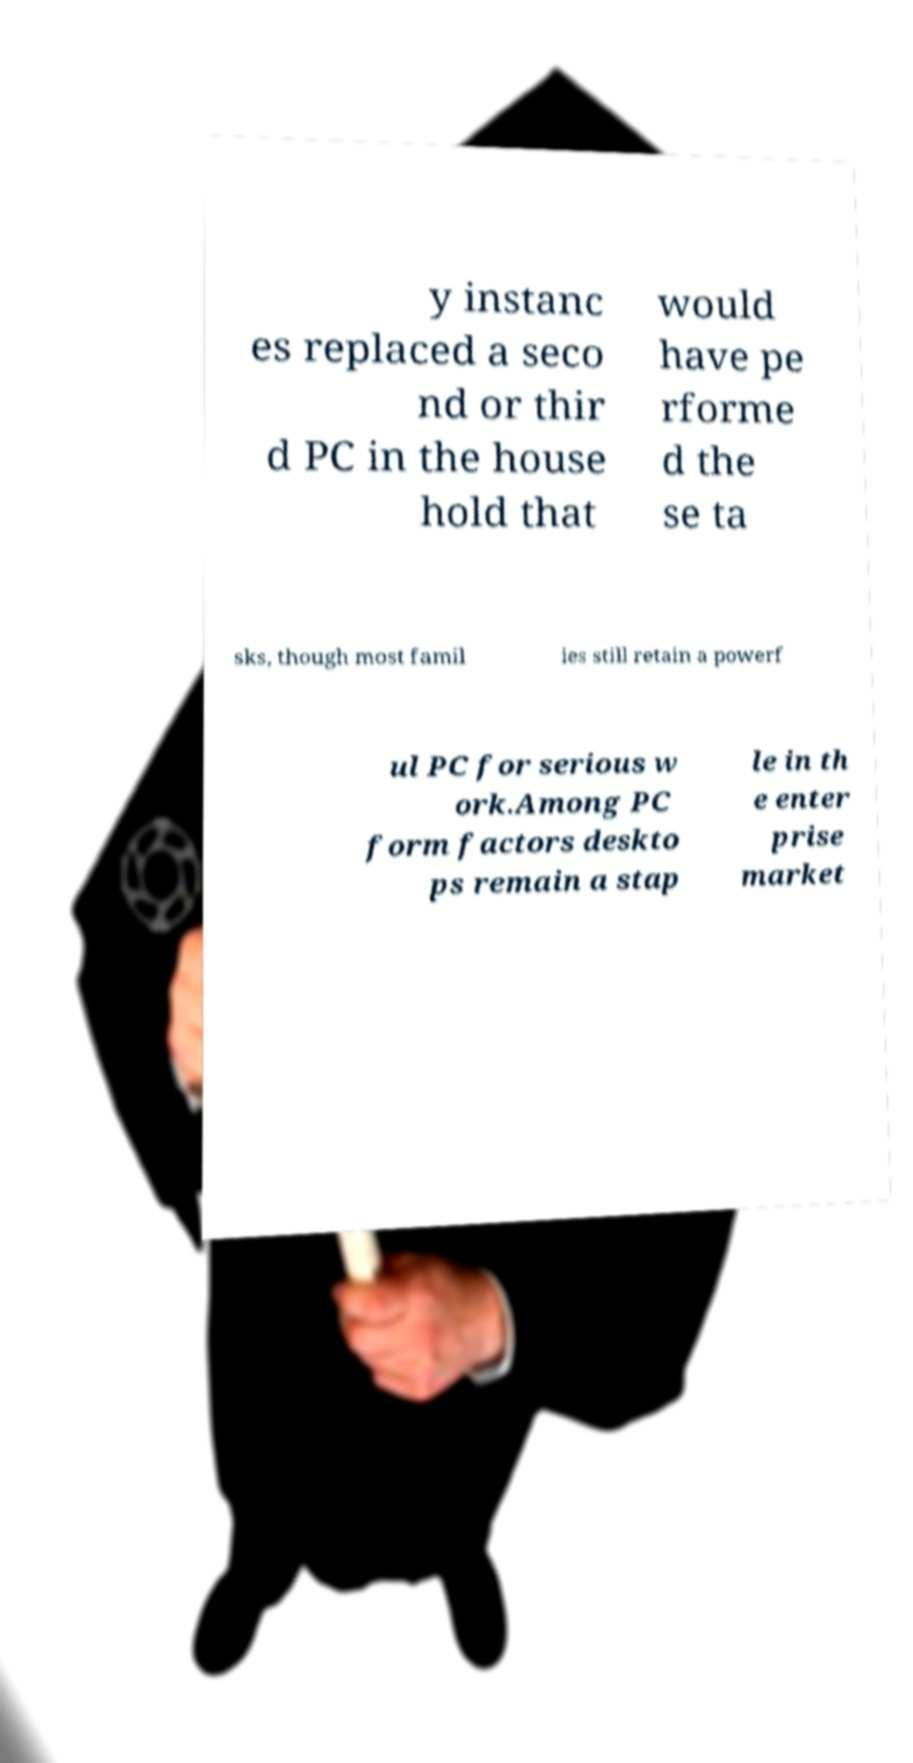Please identify and transcribe the text found in this image. y instanc es replaced a seco nd or thir d PC in the house hold that would have pe rforme d the se ta sks, though most famil ies still retain a powerf ul PC for serious w ork.Among PC form factors deskto ps remain a stap le in th e enter prise market 